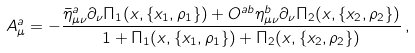<formula> <loc_0><loc_0><loc_500><loc_500>A ^ { a } _ { \mu } = - \frac { \bar { \eta } ^ { a } _ { \mu \nu } \partial _ { \nu } \Pi _ { 1 } ( x , \{ x _ { 1 } , \rho _ { 1 } \} ) + O ^ { a b } \eta ^ { b } _ { \mu \nu } \partial _ { \nu } \Pi _ { 2 } ( x , \{ x _ { 2 } , \rho _ { 2 } \} ) } { 1 + \Pi _ { 1 } ( x , \{ x _ { 1 } , \rho _ { 1 } \} ) + \Pi _ { 2 } ( x , \{ x _ { 2 } , \rho _ { 2 } \} ) } \, ,</formula> 